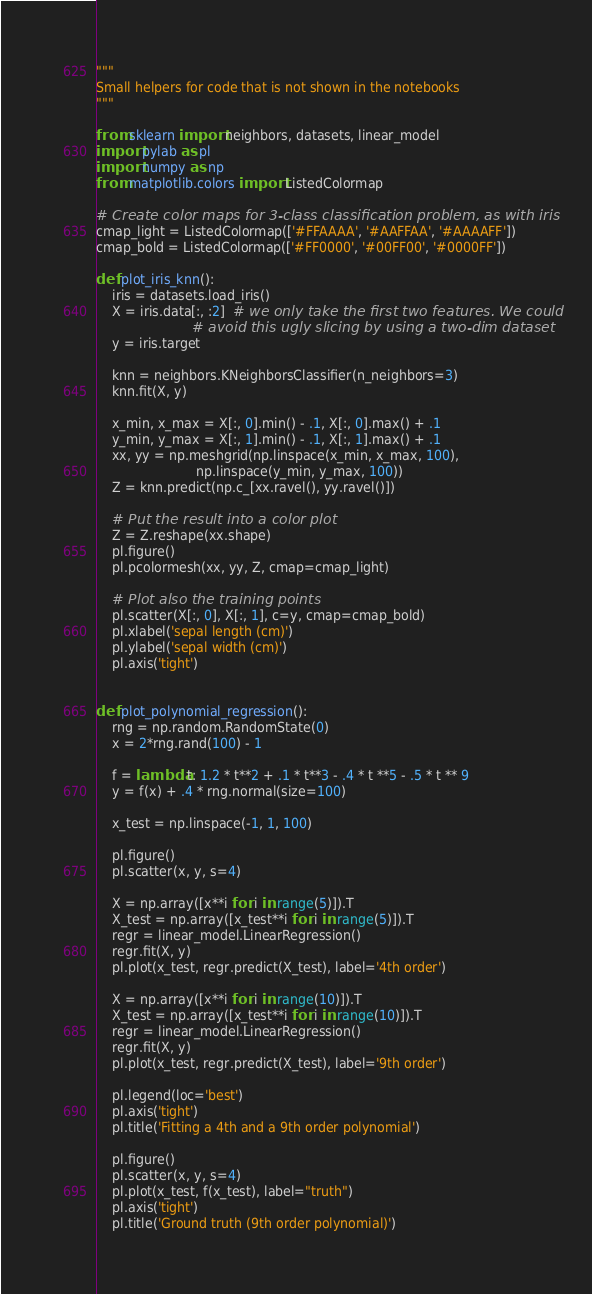<code> <loc_0><loc_0><loc_500><loc_500><_Python_>"""
Small helpers for code that is not shown in the notebooks
"""

from sklearn import neighbors, datasets, linear_model
import pylab as pl
import numpy as np
from matplotlib.colors import ListedColormap

# Create color maps for 3-class classification problem, as with iris
cmap_light = ListedColormap(['#FFAAAA', '#AAFFAA', '#AAAAFF'])
cmap_bold = ListedColormap(['#FF0000', '#00FF00', '#0000FF'])

def plot_iris_knn():
    iris = datasets.load_iris()
    X = iris.data[:, :2]  # we only take the first two features. We could
                        # avoid this ugly slicing by using a two-dim dataset
    y = iris.target

    knn = neighbors.KNeighborsClassifier(n_neighbors=3)
    knn.fit(X, y)

    x_min, x_max = X[:, 0].min() - .1, X[:, 0].max() + .1
    y_min, y_max = X[:, 1].min() - .1, X[:, 1].max() + .1
    xx, yy = np.meshgrid(np.linspace(x_min, x_max, 100),
                         np.linspace(y_min, y_max, 100))
    Z = knn.predict(np.c_[xx.ravel(), yy.ravel()])

    # Put the result into a color plot
    Z = Z.reshape(xx.shape)
    pl.figure()
    pl.pcolormesh(xx, yy, Z, cmap=cmap_light)

    # Plot also the training points
    pl.scatter(X[:, 0], X[:, 1], c=y, cmap=cmap_bold)
    pl.xlabel('sepal length (cm)')
    pl.ylabel('sepal width (cm)')
    pl.axis('tight')


def plot_polynomial_regression():
    rng = np.random.RandomState(0)
    x = 2*rng.rand(100) - 1

    f = lambda t: 1.2 * t**2 + .1 * t**3 - .4 * t **5 - .5 * t ** 9
    y = f(x) + .4 * rng.normal(size=100)

    x_test = np.linspace(-1, 1, 100)

    pl.figure()
    pl.scatter(x, y, s=4)

    X = np.array([x**i for i in range(5)]).T
    X_test = np.array([x_test**i for i in range(5)]).T
    regr = linear_model.LinearRegression()
    regr.fit(X, y)
    pl.plot(x_test, regr.predict(X_test), label='4th order')

    X = np.array([x**i for i in range(10)]).T
    X_test = np.array([x_test**i for i in range(10)]).T
    regr = linear_model.LinearRegression()
    regr.fit(X, y)
    pl.plot(x_test, regr.predict(X_test), label='9th order')

    pl.legend(loc='best')
    pl.axis('tight')
    pl.title('Fitting a 4th and a 9th order polynomial')

    pl.figure()
    pl.scatter(x, y, s=4)
    pl.plot(x_test, f(x_test), label="truth")
    pl.axis('tight')
    pl.title('Ground truth (9th order polynomial)')</code> 